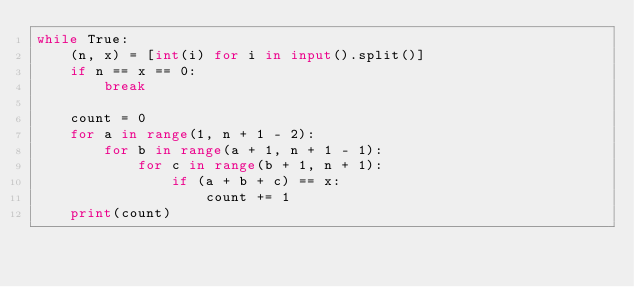<code> <loc_0><loc_0><loc_500><loc_500><_Python_>while True:
    (n, x) = [int(i) for i in input().split()]
    if n == x == 0:
        break

    count = 0
    for a in range(1, n + 1 - 2):
        for b in range(a + 1, n + 1 - 1):
            for c in range(b + 1, n + 1):
                if (a + b + c) == x:
                    count += 1
    print(count)</code> 